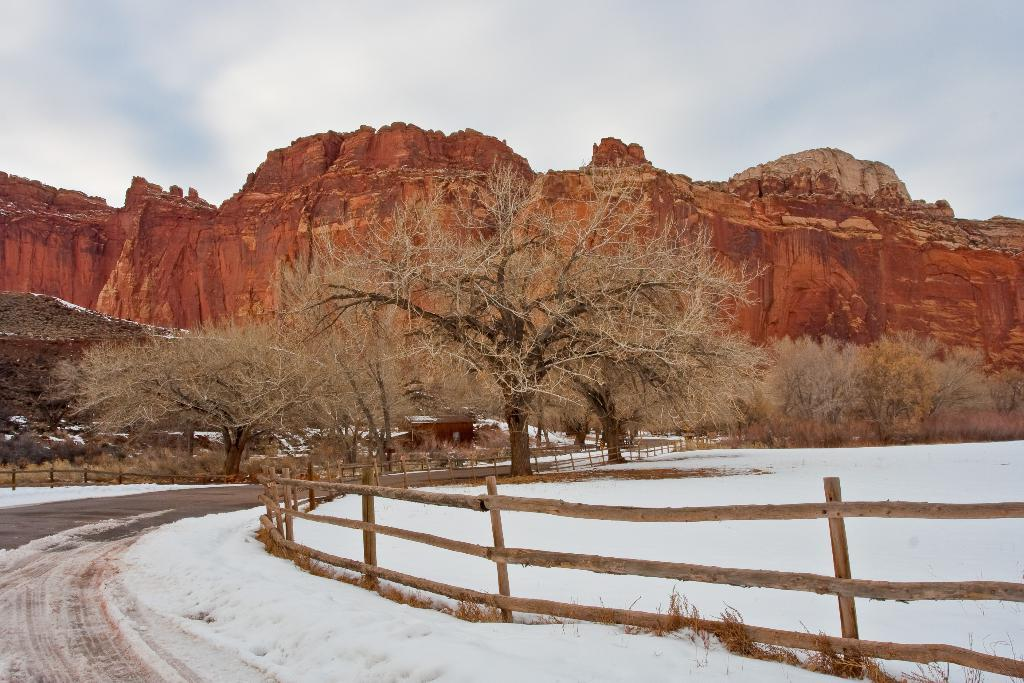What is covering the ground in the image? The ground has snow in the image. What can be seen on the ground that provides a path for walking? There is a path visible in the image. What type of barrier is present in the image? There is fencing in the image. What type of structures can be seen in the image? There are houses in the image. What type of vegetation is present in the image? Trees are present in the image. What type of natural formation is visible in the distance? Mountains are visible in the image. What is visible above the landscape? The sky is visible in the image. What type of weather condition can be inferred from the sky? Clouds are present in the sky, which suggests a partly cloudy or overcast day. How many brothers are seen playing in the snow in the image? There are no brothers or any people playing in the snow in the image. What type of insurance policy is being discussed by the people in the image? There are no people or any discussion about insurance in the image. 